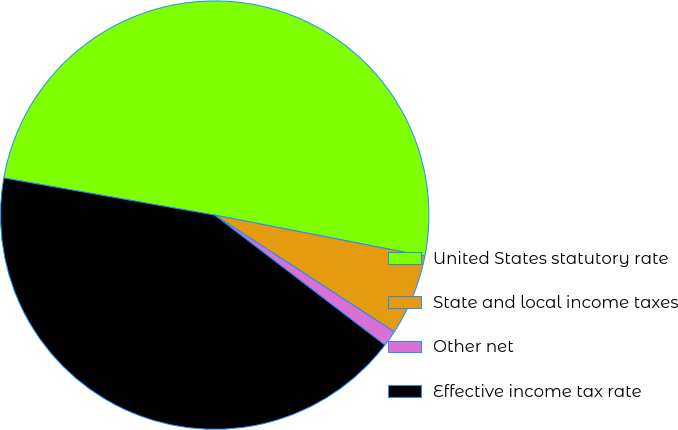Convert chart to OTSL. <chart><loc_0><loc_0><loc_500><loc_500><pie_chart><fcel>United States statutory rate<fcel>State and local income taxes<fcel>Other net<fcel>Effective income tax rate<nl><fcel>50.3%<fcel>6.11%<fcel>1.2%<fcel>42.4%<nl></chart> 